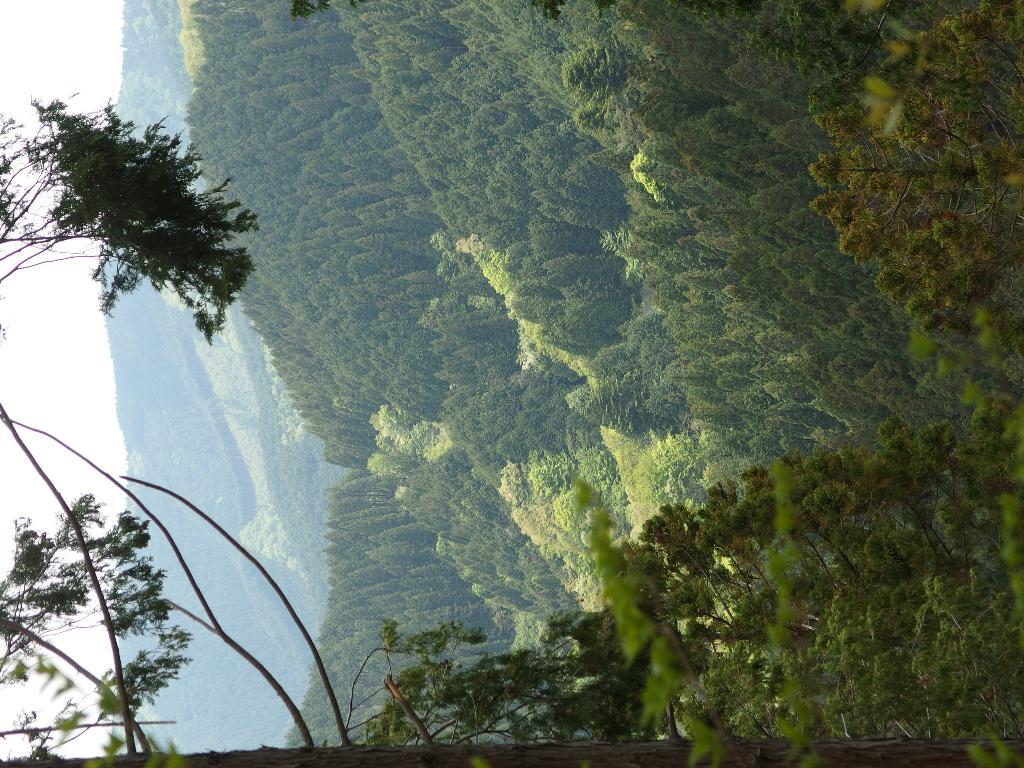What is the main subject of the image? The main subject of the image is a mountain. What can be seen on the mountain in the image? There are trees on the mountain in the image. What is visible at the top of the mountain in the image? The sky is visible at the top of the mountain in the image. How many feathers can be seen on the mountain in the image? There are no feathers present on the mountain in the image. What type of learning is taking place on the mountain in the image? There is no learning activity depicted in the image; it features a mountain with trees and a visible sky. 